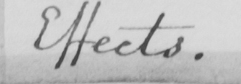What text is written in this handwritten line? Effects . 